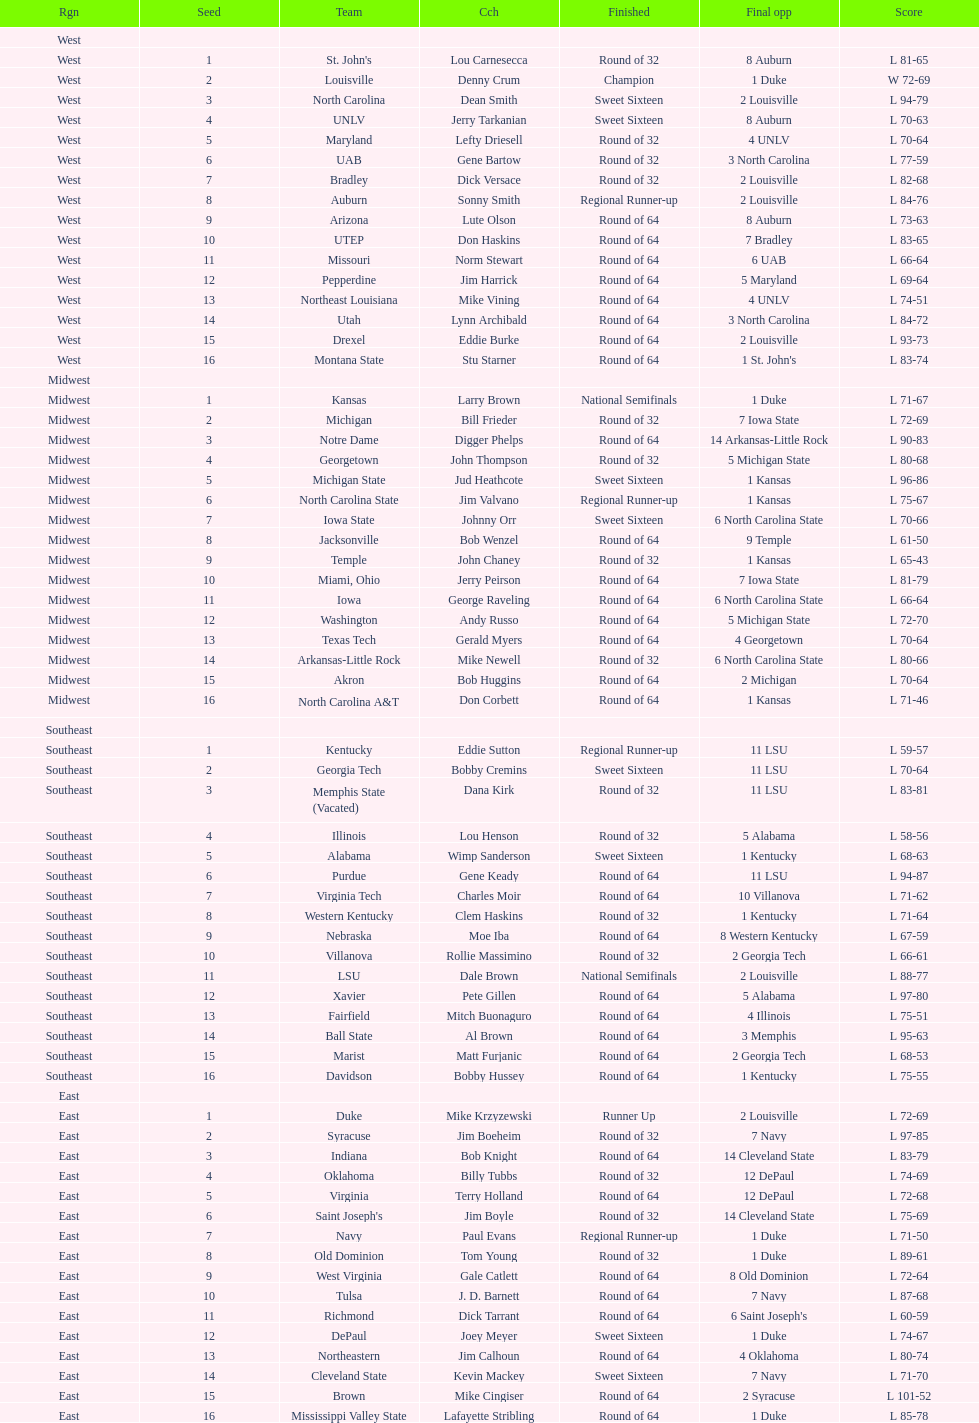What's the total count of teams in the east region? 16. 